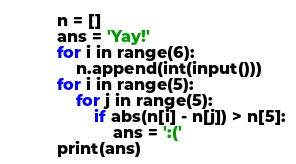<code> <loc_0><loc_0><loc_500><loc_500><_Python_>n = []
ans = 'Yay!'
for i in range(6):
    n.append(int(input()))
for i in range(5):
    for j in range(5):
        if abs(n[i] - n[j]) > n[5]:
            ans = ':('
print(ans)
</code> 